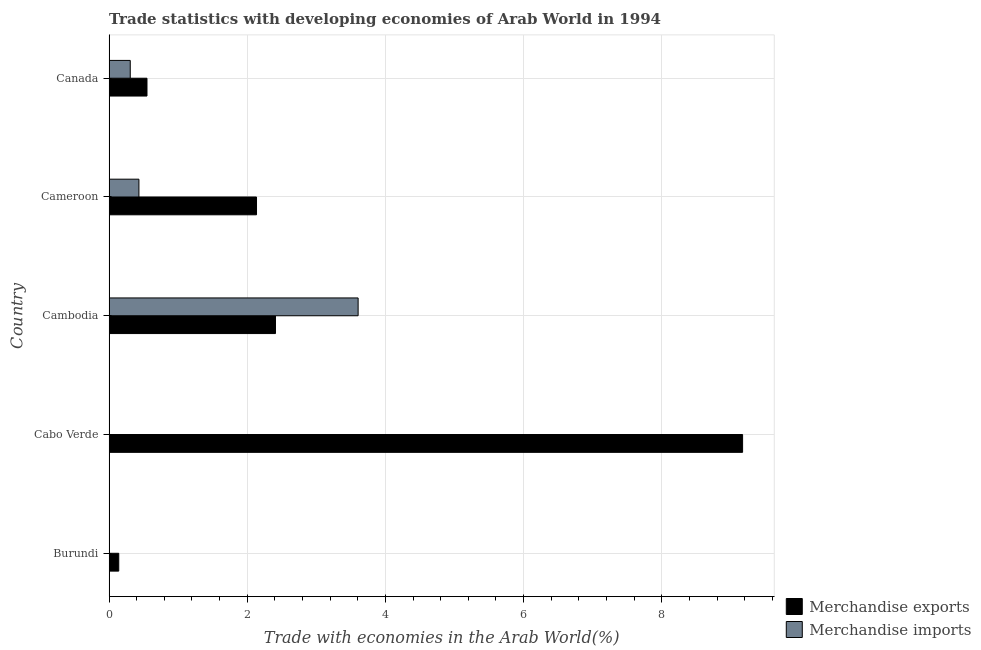How many different coloured bars are there?
Keep it short and to the point. 2. Are the number of bars per tick equal to the number of legend labels?
Offer a very short reply. Yes. Are the number of bars on each tick of the Y-axis equal?
Provide a short and direct response. Yes. How many bars are there on the 2nd tick from the top?
Give a very brief answer. 2. How many bars are there on the 3rd tick from the bottom?
Your answer should be compact. 2. What is the label of the 5th group of bars from the top?
Ensure brevity in your answer.  Burundi. What is the merchandise exports in Burundi?
Offer a terse response. 0.14. Across all countries, what is the maximum merchandise imports?
Your response must be concise. 3.6. Across all countries, what is the minimum merchandise exports?
Keep it short and to the point. 0.14. In which country was the merchandise imports maximum?
Keep it short and to the point. Cambodia. In which country was the merchandise imports minimum?
Keep it short and to the point. Cabo Verde. What is the total merchandise exports in the graph?
Your response must be concise. 14.4. What is the difference between the merchandise imports in Cabo Verde and that in Cambodia?
Ensure brevity in your answer.  -3.6. What is the difference between the merchandise exports in Canada and the merchandise imports in Cabo Verde?
Keep it short and to the point. 0.55. What is the average merchandise exports per country?
Offer a terse response. 2.88. What is the difference between the merchandise exports and merchandise imports in Burundi?
Make the answer very short. 0.14. What is the ratio of the merchandise imports in Cambodia to that in Cameroon?
Give a very brief answer. 8.34. What is the difference between the highest and the second highest merchandise exports?
Offer a terse response. 6.76. What is the difference between the highest and the lowest merchandise exports?
Keep it short and to the point. 9.03. Is the sum of the merchandise imports in Burundi and Cameroon greater than the maximum merchandise exports across all countries?
Offer a terse response. No. What does the 2nd bar from the top in Cameroon represents?
Provide a succinct answer. Merchandise exports. How many bars are there?
Provide a short and direct response. 10. Are all the bars in the graph horizontal?
Make the answer very short. Yes. How many countries are there in the graph?
Ensure brevity in your answer.  5. Are the values on the major ticks of X-axis written in scientific E-notation?
Offer a very short reply. No. Does the graph contain any zero values?
Provide a short and direct response. No. Does the graph contain grids?
Offer a terse response. Yes. What is the title of the graph?
Your response must be concise. Trade statistics with developing economies of Arab World in 1994. What is the label or title of the X-axis?
Your answer should be compact. Trade with economies in the Arab World(%). What is the label or title of the Y-axis?
Ensure brevity in your answer.  Country. What is the Trade with economies in the Arab World(%) of Merchandise exports in Burundi?
Your answer should be very brief. 0.14. What is the Trade with economies in the Arab World(%) in Merchandise imports in Burundi?
Ensure brevity in your answer.  0. What is the Trade with economies in the Arab World(%) of Merchandise exports in Cabo Verde?
Make the answer very short. 9.17. What is the Trade with economies in the Arab World(%) in Merchandise imports in Cabo Verde?
Provide a succinct answer. 0. What is the Trade with economies in the Arab World(%) of Merchandise exports in Cambodia?
Make the answer very short. 2.41. What is the Trade with economies in the Arab World(%) of Merchandise imports in Cambodia?
Your response must be concise. 3.6. What is the Trade with economies in the Arab World(%) in Merchandise exports in Cameroon?
Make the answer very short. 2.13. What is the Trade with economies in the Arab World(%) of Merchandise imports in Cameroon?
Ensure brevity in your answer.  0.43. What is the Trade with economies in the Arab World(%) in Merchandise exports in Canada?
Keep it short and to the point. 0.55. What is the Trade with economies in the Arab World(%) of Merchandise imports in Canada?
Offer a very short reply. 0.31. Across all countries, what is the maximum Trade with economies in the Arab World(%) in Merchandise exports?
Ensure brevity in your answer.  9.17. Across all countries, what is the maximum Trade with economies in the Arab World(%) of Merchandise imports?
Offer a very short reply. 3.6. Across all countries, what is the minimum Trade with economies in the Arab World(%) in Merchandise exports?
Ensure brevity in your answer.  0.14. Across all countries, what is the minimum Trade with economies in the Arab World(%) in Merchandise imports?
Your answer should be compact. 0. What is the total Trade with economies in the Arab World(%) in Merchandise exports in the graph?
Offer a very short reply. 14.4. What is the total Trade with economies in the Arab World(%) in Merchandise imports in the graph?
Ensure brevity in your answer.  4.35. What is the difference between the Trade with economies in the Arab World(%) of Merchandise exports in Burundi and that in Cabo Verde?
Ensure brevity in your answer.  -9.03. What is the difference between the Trade with economies in the Arab World(%) in Merchandise imports in Burundi and that in Cabo Verde?
Give a very brief answer. 0. What is the difference between the Trade with economies in the Arab World(%) of Merchandise exports in Burundi and that in Cambodia?
Offer a very short reply. -2.27. What is the difference between the Trade with economies in the Arab World(%) of Merchandise imports in Burundi and that in Cambodia?
Offer a very short reply. -3.6. What is the difference between the Trade with economies in the Arab World(%) of Merchandise exports in Burundi and that in Cameroon?
Offer a very short reply. -1.99. What is the difference between the Trade with economies in the Arab World(%) of Merchandise imports in Burundi and that in Cameroon?
Your response must be concise. -0.43. What is the difference between the Trade with economies in the Arab World(%) in Merchandise exports in Burundi and that in Canada?
Ensure brevity in your answer.  -0.41. What is the difference between the Trade with economies in the Arab World(%) in Merchandise imports in Burundi and that in Canada?
Provide a succinct answer. -0.3. What is the difference between the Trade with economies in the Arab World(%) of Merchandise exports in Cabo Verde and that in Cambodia?
Your answer should be very brief. 6.76. What is the difference between the Trade with economies in the Arab World(%) of Merchandise imports in Cabo Verde and that in Cambodia?
Provide a short and direct response. -3.6. What is the difference between the Trade with economies in the Arab World(%) in Merchandise exports in Cabo Verde and that in Cameroon?
Provide a succinct answer. 7.04. What is the difference between the Trade with economies in the Arab World(%) of Merchandise imports in Cabo Verde and that in Cameroon?
Keep it short and to the point. -0.43. What is the difference between the Trade with economies in the Arab World(%) in Merchandise exports in Cabo Verde and that in Canada?
Your response must be concise. 8.62. What is the difference between the Trade with economies in the Arab World(%) of Merchandise imports in Cabo Verde and that in Canada?
Offer a very short reply. -0.3. What is the difference between the Trade with economies in the Arab World(%) of Merchandise exports in Cambodia and that in Cameroon?
Provide a succinct answer. 0.27. What is the difference between the Trade with economies in the Arab World(%) of Merchandise imports in Cambodia and that in Cameroon?
Provide a succinct answer. 3.17. What is the difference between the Trade with economies in the Arab World(%) in Merchandise exports in Cambodia and that in Canada?
Give a very brief answer. 1.86. What is the difference between the Trade with economies in the Arab World(%) of Merchandise imports in Cambodia and that in Canada?
Make the answer very short. 3.3. What is the difference between the Trade with economies in the Arab World(%) in Merchandise exports in Cameroon and that in Canada?
Give a very brief answer. 1.59. What is the difference between the Trade with economies in the Arab World(%) in Merchandise imports in Cameroon and that in Canada?
Keep it short and to the point. 0.13. What is the difference between the Trade with economies in the Arab World(%) in Merchandise exports in Burundi and the Trade with economies in the Arab World(%) in Merchandise imports in Cabo Verde?
Provide a succinct answer. 0.14. What is the difference between the Trade with economies in the Arab World(%) in Merchandise exports in Burundi and the Trade with economies in the Arab World(%) in Merchandise imports in Cambodia?
Your response must be concise. -3.46. What is the difference between the Trade with economies in the Arab World(%) in Merchandise exports in Burundi and the Trade with economies in the Arab World(%) in Merchandise imports in Cameroon?
Keep it short and to the point. -0.29. What is the difference between the Trade with economies in the Arab World(%) in Merchandise exports in Burundi and the Trade with economies in the Arab World(%) in Merchandise imports in Canada?
Offer a terse response. -0.17. What is the difference between the Trade with economies in the Arab World(%) of Merchandise exports in Cabo Verde and the Trade with economies in the Arab World(%) of Merchandise imports in Cambodia?
Ensure brevity in your answer.  5.56. What is the difference between the Trade with economies in the Arab World(%) of Merchandise exports in Cabo Verde and the Trade with economies in the Arab World(%) of Merchandise imports in Cameroon?
Keep it short and to the point. 8.74. What is the difference between the Trade with economies in the Arab World(%) of Merchandise exports in Cabo Verde and the Trade with economies in the Arab World(%) of Merchandise imports in Canada?
Give a very brief answer. 8.86. What is the difference between the Trade with economies in the Arab World(%) in Merchandise exports in Cambodia and the Trade with economies in the Arab World(%) in Merchandise imports in Cameroon?
Ensure brevity in your answer.  1.98. What is the difference between the Trade with economies in the Arab World(%) of Merchandise exports in Cambodia and the Trade with economies in the Arab World(%) of Merchandise imports in Canada?
Make the answer very short. 2.1. What is the difference between the Trade with economies in the Arab World(%) of Merchandise exports in Cameroon and the Trade with economies in the Arab World(%) of Merchandise imports in Canada?
Provide a succinct answer. 1.83. What is the average Trade with economies in the Arab World(%) of Merchandise exports per country?
Your answer should be compact. 2.88. What is the average Trade with economies in the Arab World(%) in Merchandise imports per country?
Provide a short and direct response. 0.87. What is the difference between the Trade with economies in the Arab World(%) in Merchandise exports and Trade with economies in the Arab World(%) in Merchandise imports in Burundi?
Give a very brief answer. 0.14. What is the difference between the Trade with economies in the Arab World(%) of Merchandise exports and Trade with economies in the Arab World(%) of Merchandise imports in Cabo Verde?
Give a very brief answer. 9.17. What is the difference between the Trade with economies in the Arab World(%) of Merchandise exports and Trade with economies in the Arab World(%) of Merchandise imports in Cambodia?
Your response must be concise. -1.2. What is the difference between the Trade with economies in the Arab World(%) of Merchandise exports and Trade with economies in the Arab World(%) of Merchandise imports in Cameroon?
Your answer should be very brief. 1.7. What is the difference between the Trade with economies in the Arab World(%) in Merchandise exports and Trade with economies in the Arab World(%) in Merchandise imports in Canada?
Offer a terse response. 0.24. What is the ratio of the Trade with economies in the Arab World(%) in Merchandise exports in Burundi to that in Cabo Verde?
Ensure brevity in your answer.  0.02. What is the ratio of the Trade with economies in the Arab World(%) of Merchandise imports in Burundi to that in Cabo Verde?
Provide a succinct answer. 2.02. What is the ratio of the Trade with economies in the Arab World(%) in Merchandise exports in Burundi to that in Cambodia?
Provide a short and direct response. 0.06. What is the ratio of the Trade with economies in the Arab World(%) of Merchandise imports in Burundi to that in Cambodia?
Offer a very short reply. 0. What is the ratio of the Trade with economies in the Arab World(%) of Merchandise exports in Burundi to that in Cameroon?
Make the answer very short. 0.07. What is the ratio of the Trade with economies in the Arab World(%) in Merchandise imports in Burundi to that in Cameroon?
Your response must be concise. 0.01. What is the ratio of the Trade with economies in the Arab World(%) of Merchandise exports in Burundi to that in Canada?
Your answer should be compact. 0.26. What is the ratio of the Trade with economies in the Arab World(%) of Merchandise imports in Burundi to that in Canada?
Your answer should be compact. 0.01. What is the ratio of the Trade with economies in the Arab World(%) in Merchandise exports in Cabo Verde to that in Cambodia?
Provide a short and direct response. 3.81. What is the ratio of the Trade with economies in the Arab World(%) in Merchandise exports in Cabo Verde to that in Cameroon?
Give a very brief answer. 4.3. What is the ratio of the Trade with economies in the Arab World(%) of Merchandise imports in Cabo Verde to that in Cameroon?
Provide a succinct answer. 0. What is the ratio of the Trade with economies in the Arab World(%) of Merchandise exports in Cabo Verde to that in Canada?
Your answer should be compact. 16.71. What is the ratio of the Trade with economies in the Arab World(%) of Merchandise imports in Cabo Verde to that in Canada?
Ensure brevity in your answer.  0.01. What is the ratio of the Trade with economies in the Arab World(%) in Merchandise exports in Cambodia to that in Cameroon?
Your answer should be compact. 1.13. What is the ratio of the Trade with economies in the Arab World(%) of Merchandise imports in Cambodia to that in Cameroon?
Provide a succinct answer. 8.34. What is the ratio of the Trade with economies in the Arab World(%) in Merchandise exports in Cambodia to that in Canada?
Provide a short and direct response. 4.39. What is the ratio of the Trade with economies in the Arab World(%) in Merchandise imports in Cambodia to that in Canada?
Make the answer very short. 11.76. What is the ratio of the Trade with economies in the Arab World(%) in Merchandise exports in Cameroon to that in Canada?
Make the answer very short. 3.89. What is the ratio of the Trade with economies in the Arab World(%) of Merchandise imports in Cameroon to that in Canada?
Keep it short and to the point. 1.41. What is the difference between the highest and the second highest Trade with economies in the Arab World(%) in Merchandise exports?
Your answer should be compact. 6.76. What is the difference between the highest and the second highest Trade with economies in the Arab World(%) in Merchandise imports?
Offer a very short reply. 3.17. What is the difference between the highest and the lowest Trade with economies in the Arab World(%) of Merchandise exports?
Give a very brief answer. 9.03. What is the difference between the highest and the lowest Trade with economies in the Arab World(%) in Merchandise imports?
Provide a short and direct response. 3.6. 